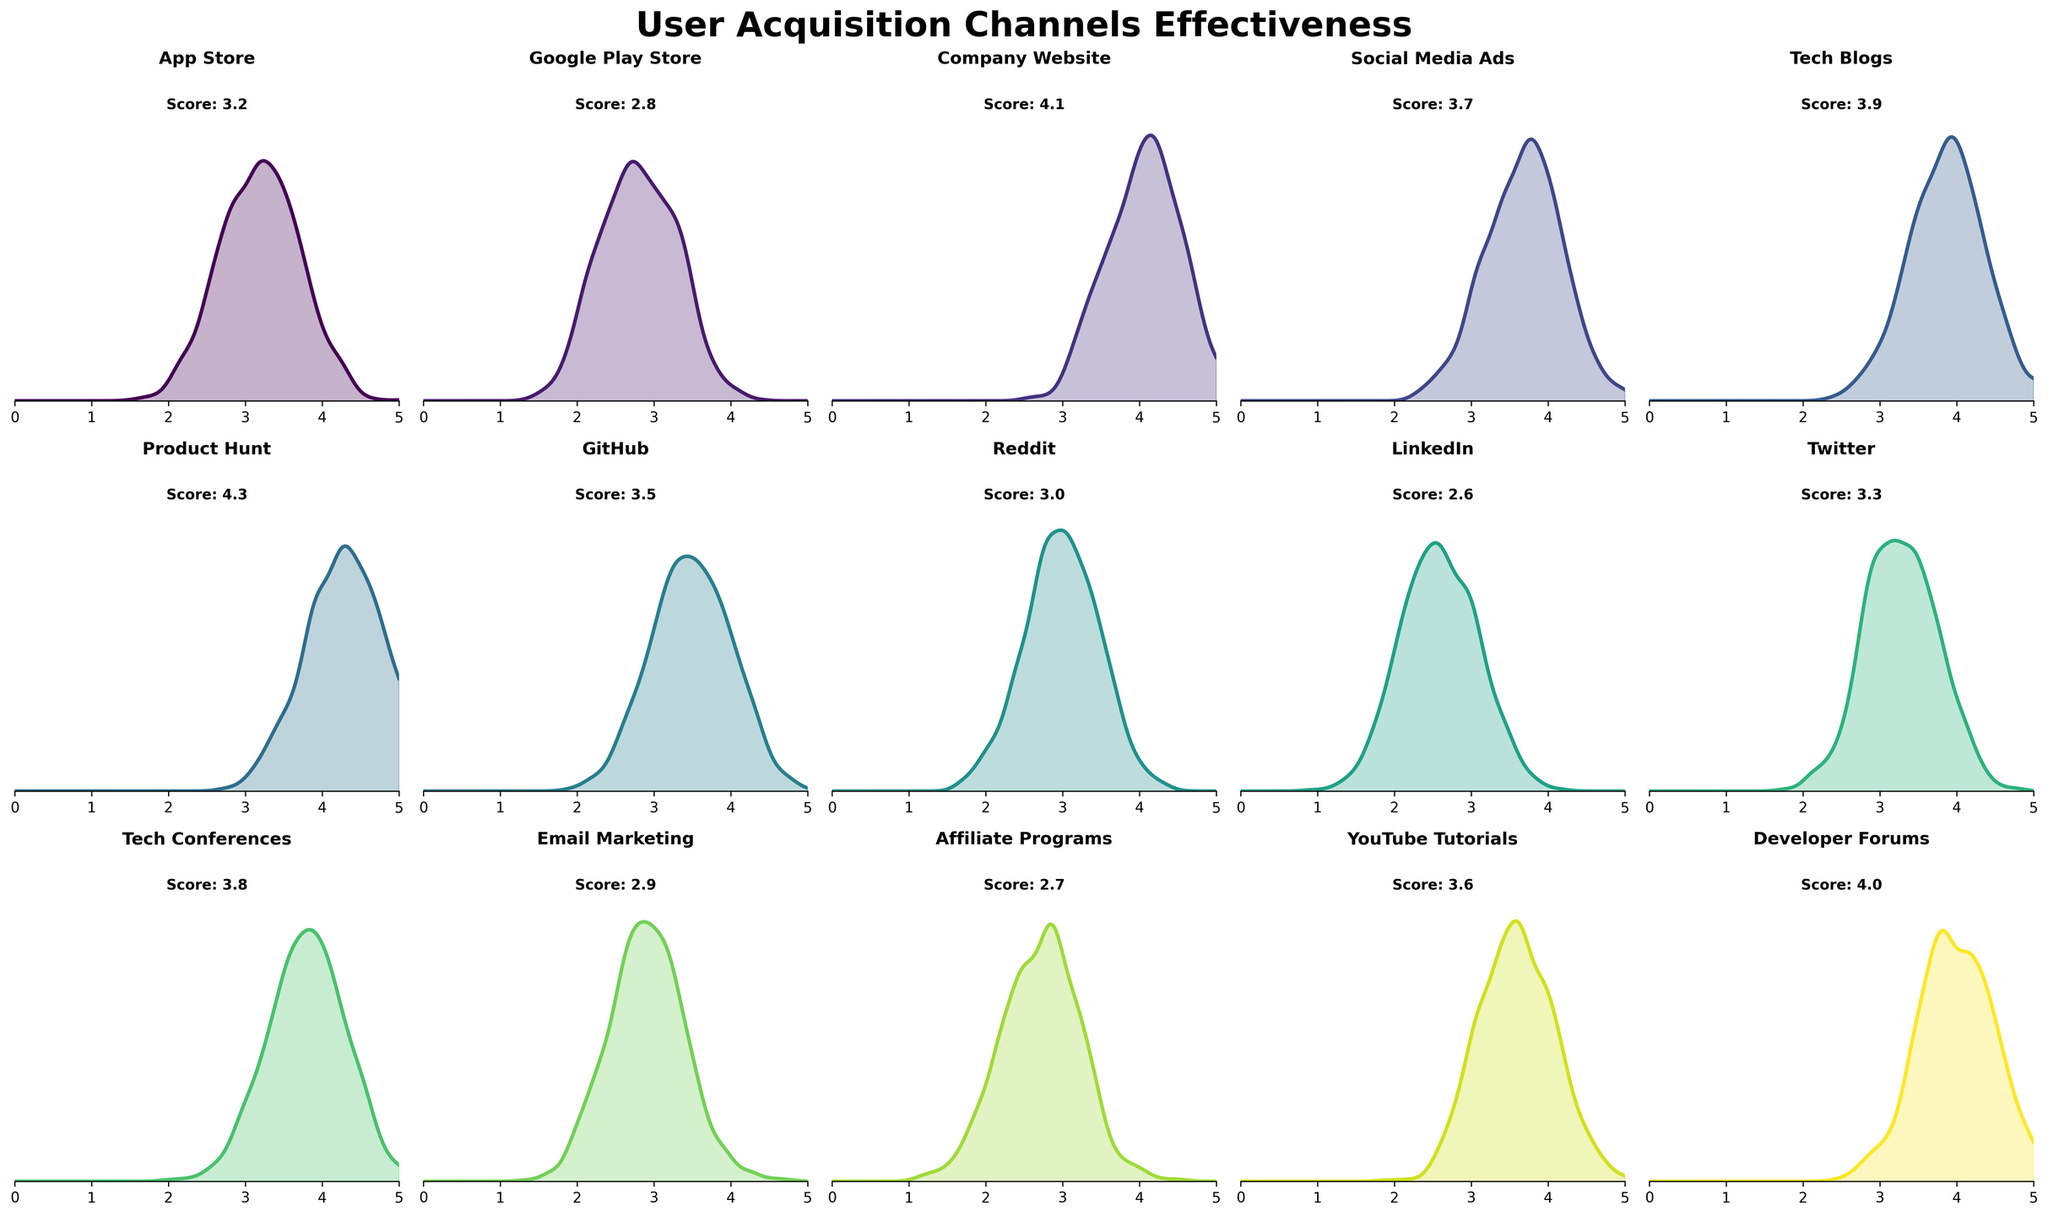What is the title of the figure? The title of the figure is the large text displayed at the top center of the figure. Here, it reads 'User Acquisition Channels Effectiveness', indicating what the detailed subplots are focusing on
Answer: User Acquisition Channels Effectiveness How many channels are represented in the figure? To determine the number of channels, you count the individual subplots within the figure. Each subplot corresponds to one channel, and since there are 15 subplots, we can conclude that there are 15 channels represented
Answer: 15 What is the effectiveness score indicated on the subplot for 'Product Hunt'? The effectiveness score for 'Product Hunt' is prominently displayed inside the subplot dedicated to it, typically at the top right corner. Here, it shows a score of 4.3
Answer: 4.3 Which channel has the highest effectiveness score? By scanning through the scores displayed in each subplot, 'Product Hunt' has the highest score of 4.3 compared to all others
Answer: Product Hunt What is the average effectiveness score across all channels? To find the average effectiveness score, add up all the scores and then divide by the number of channels: (3.2 + 2.8 + 4.1 + 3.7 + 3.9 + 4.3 + 3.5 + 3.0 + 2.6 + 3.3 + 3.8 + 2.9 + 2.7 + 3.6 + 4.0) / 15 = 3.4333
Answer: 3.43 What is the difference in effectiveness score between 'Company Website' and 'App Store'? Subtract the effectiveness score of 'App Store' from that of 'Company Website': 4.1 - 3.2 = 0.9
Answer: 0.9 Which channel has a more effective user acquisition according to its density plot: 'Email Marketing' or 'Tech Blogs'? By evaluating the density plots for both channels, 'Tech Blogs' shows a higher concentration score centered around 3.9, while 'Email Marketing' is centered around 2.9, indicating 'Tech Blogs' is more effective
Answer: Tech Blogs Comparing 'LinkedIn' and 'Reddit', which channel appears to have higher density in their respective plots? The density plot for 'Reddit' appears to have a higher peak, indicating a higher concentration of effectiveness compared to 'LinkedIn', which looks flatter
Answer: Reddit Which channels have effectiveness scores that are lower than 3.0? To find this, check each subplot's displayed score and identify those below 3.0. The channels are: 'Google Play Store' (2.8), 'LinkedIn' (2.6), 'Affiliate Programs' (2.7), and 'Email Marketing' (2.9)
Answer: Google Play Store, LinkedIn, Affiliate Programs, Email Marketing What's the range of the effectiveness scores represented in the figure? To find the range, subtract the smallest score from the largest score. The smallest score is 2.6 (LinkedIn) and the largest is 4.3 (Product Hunt), so the range is 4.3 - 2.6 = 1.7
Answer: 1.7 